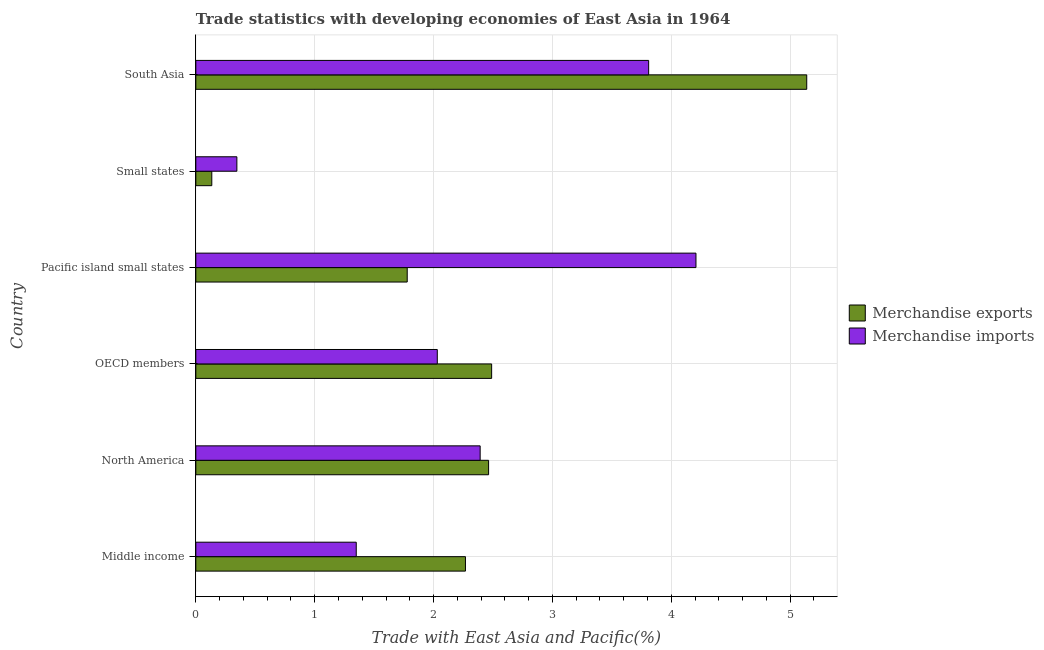How many different coloured bars are there?
Your answer should be compact. 2. Are the number of bars per tick equal to the number of legend labels?
Your response must be concise. Yes. What is the label of the 3rd group of bars from the top?
Your answer should be very brief. Pacific island small states. In how many cases, is the number of bars for a given country not equal to the number of legend labels?
Ensure brevity in your answer.  0. What is the merchandise exports in OECD members?
Ensure brevity in your answer.  2.49. Across all countries, what is the maximum merchandise imports?
Your response must be concise. 4.21. Across all countries, what is the minimum merchandise exports?
Make the answer very short. 0.13. In which country was the merchandise imports maximum?
Make the answer very short. Pacific island small states. In which country was the merchandise imports minimum?
Your response must be concise. Small states. What is the total merchandise imports in the graph?
Your response must be concise. 14.14. What is the difference between the merchandise imports in North America and that in Small states?
Provide a short and direct response. 2.05. What is the difference between the merchandise imports in Pacific island small states and the merchandise exports in Small states?
Ensure brevity in your answer.  4.07. What is the average merchandise imports per country?
Your answer should be compact. 2.36. What is the difference between the merchandise imports and merchandise exports in Small states?
Ensure brevity in your answer.  0.21. In how many countries, is the merchandise imports greater than 3.4 %?
Your response must be concise. 2. What is the ratio of the merchandise imports in North America to that in Pacific island small states?
Offer a terse response. 0.57. Is the difference between the merchandise exports in OECD members and Small states greater than the difference between the merchandise imports in OECD members and Small states?
Ensure brevity in your answer.  Yes. What is the difference between the highest and the second highest merchandise imports?
Ensure brevity in your answer.  0.4. What is the difference between the highest and the lowest merchandise exports?
Your response must be concise. 5.01. What does the 2nd bar from the top in OECD members represents?
Your response must be concise. Merchandise exports. What does the 1st bar from the bottom in OECD members represents?
Your response must be concise. Merchandise exports. Are all the bars in the graph horizontal?
Give a very brief answer. Yes. How many countries are there in the graph?
Make the answer very short. 6. What is the difference between two consecutive major ticks on the X-axis?
Keep it short and to the point. 1. How are the legend labels stacked?
Your response must be concise. Vertical. What is the title of the graph?
Keep it short and to the point. Trade statistics with developing economies of East Asia in 1964. Does "US$" appear as one of the legend labels in the graph?
Give a very brief answer. No. What is the label or title of the X-axis?
Your answer should be very brief. Trade with East Asia and Pacific(%). What is the label or title of the Y-axis?
Provide a succinct answer. Country. What is the Trade with East Asia and Pacific(%) in Merchandise exports in Middle income?
Your answer should be compact. 2.27. What is the Trade with East Asia and Pacific(%) of Merchandise imports in Middle income?
Offer a terse response. 1.35. What is the Trade with East Asia and Pacific(%) in Merchandise exports in North America?
Your response must be concise. 2.46. What is the Trade with East Asia and Pacific(%) in Merchandise imports in North America?
Provide a short and direct response. 2.39. What is the Trade with East Asia and Pacific(%) in Merchandise exports in OECD members?
Offer a terse response. 2.49. What is the Trade with East Asia and Pacific(%) of Merchandise imports in OECD members?
Keep it short and to the point. 2.03. What is the Trade with East Asia and Pacific(%) of Merchandise exports in Pacific island small states?
Provide a succinct answer. 1.78. What is the Trade with East Asia and Pacific(%) in Merchandise imports in Pacific island small states?
Offer a terse response. 4.21. What is the Trade with East Asia and Pacific(%) in Merchandise exports in Small states?
Keep it short and to the point. 0.13. What is the Trade with East Asia and Pacific(%) in Merchandise imports in Small states?
Your response must be concise. 0.35. What is the Trade with East Asia and Pacific(%) in Merchandise exports in South Asia?
Provide a succinct answer. 5.14. What is the Trade with East Asia and Pacific(%) in Merchandise imports in South Asia?
Provide a short and direct response. 3.81. Across all countries, what is the maximum Trade with East Asia and Pacific(%) in Merchandise exports?
Ensure brevity in your answer.  5.14. Across all countries, what is the maximum Trade with East Asia and Pacific(%) in Merchandise imports?
Provide a succinct answer. 4.21. Across all countries, what is the minimum Trade with East Asia and Pacific(%) of Merchandise exports?
Keep it short and to the point. 0.13. Across all countries, what is the minimum Trade with East Asia and Pacific(%) of Merchandise imports?
Your answer should be very brief. 0.35. What is the total Trade with East Asia and Pacific(%) of Merchandise exports in the graph?
Provide a succinct answer. 14.27. What is the total Trade with East Asia and Pacific(%) in Merchandise imports in the graph?
Offer a very short reply. 14.14. What is the difference between the Trade with East Asia and Pacific(%) in Merchandise exports in Middle income and that in North America?
Offer a terse response. -0.19. What is the difference between the Trade with East Asia and Pacific(%) in Merchandise imports in Middle income and that in North America?
Your response must be concise. -1.04. What is the difference between the Trade with East Asia and Pacific(%) in Merchandise exports in Middle income and that in OECD members?
Offer a terse response. -0.22. What is the difference between the Trade with East Asia and Pacific(%) of Merchandise imports in Middle income and that in OECD members?
Offer a terse response. -0.68. What is the difference between the Trade with East Asia and Pacific(%) in Merchandise exports in Middle income and that in Pacific island small states?
Your answer should be compact. 0.49. What is the difference between the Trade with East Asia and Pacific(%) of Merchandise imports in Middle income and that in Pacific island small states?
Offer a terse response. -2.86. What is the difference between the Trade with East Asia and Pacific(%) of Merchandise exports in Middle income and that in Small states?
Your response must be concise. 2.13. What is the difference between the Trade with East Asia and Pacific(%) in Merchandise imports in Middle income and that in Small states?
Ensure brevity in your answer.  1. What is the difference between the Trade with East Asia and Pacific(%) of Merchandise exports in Middle income and that in South Asia?
Provide a succinct answer. -2.87. What is the difference between the Trade with East Asia and Pacific(%) in Merchandise imports in Middle income and that in South Asia?
Your response must be concise. -2.46. What is the difference between the Trade with East Asia and Pacific(%) in Merchandise exports in North America and that in OECD members?
Give a very brief answer. -0.03. What is the difference between the Trade with East Asia and Pacific(%) of Merchandise imports in North America and that in OECD members?
Your response must be concise. 0.36. What is the difference between the Trade with East Asia and Pacific(%) of Merchandise exports in North America and that in Pacific island small states?
Offer a terse response. 0.68. What is the difference between the Trade with East Asia and Pacific(%) of Merchandise imports in North America and that in Pacific island small states?
Offer a very short reply. -1.82. What is the difference between the Trade with East Asia and Pacific(%) of Merchandise exports in North America and that in Small states?
Your answer should be very brief. 2.33. What is the difference between the Trade with East Asia and Pacific(%) in Merchandise imports in North America and that in Small states?
Ensure brevity in your answer.  2.05. What is the difference between the Trade with East Asia and Pacific(%) of Merchandise exports in North America and that in South Asia?
Your answer should be very brief. -2.68. What is the difference between the Trade with East Asia and Pacific(%) in Merchandise imports in North America and that in South Asia?
Offer a very short reply. -1.42. What is the difference between the Trade with East Asia and Pacific(%) in Merchandise exports in OECD members and that in Pacific island small states?
Ensure brevity in your answer.  0.71. What is the difference between the Trade with East Asia and Pacific(%) in Merchandise imports in OECD members and that in Pacific island small states?
Keep it short and to the point. -2.18. What is the difference between the Trade with East Asia and Pacific(%) of Merchandise exports in OECD members and that in Small states?
Provide a succinct answer. 2.35. What is the difference between the Trade with East Asia and Pacific(%) of Merchandise imports in OECD members and that in Small states?
Your answer should be very brief. 1.69. What is the difference between the Trade with East Asia and Pacific(%) of Merchandise exports in OECD members and that in South Asia?
Provide a short and direct response. -2.65. What is the difference between the Trade with East Asia and Pacific(%) in Merchandise imports in OECD members and that in South Asia?
Keep it short and to the point. -1.78. What is the difference between the Trade with East Asia and Pacific(%) in Merchandise exports in Pacific island small states and that in Small states?
Provide a succinct answer. 1.64. What is the difference between the Trade with East Asia and Pacific(%) in Merchandise imports in Pacific island small states and that in Small states?
Make the answer very short. 3.86. What is the difference between the Trade with East Asia and Pacific(%) in Merchandise exports in Pacific island small states and that in South Asia?
Offer a very short reply. -3.36. What is the difference between the Trade with East Asia and Pacific(%) in Merchandise imports in Pacific island small states and that in South Asia?
Offer a very short reply. 0.4. What is the difference between the Trade with East Asia and Pacific(%) of Merchandise exports in Small states and that in South Asia?
Your response must be concise. -5.01. What is the difference between the Trade with East Asia and Pacific(%) of Merchandise imports in Small states and that in South Asia?
Offer a terse response. -3.46. What is the difference between the Trade with East Asia and Pacific(%) of Merchandise exports in Middle income and the Trade with East Asia and Pacific(%) of Merchandise imports in North America?
Offer a terse response. -0.12. What is the difference between the Trade with East Asia and Pacific(%) in Merchandise exports in Middle income and the Trade with East Asia and Pacific(%) in Merchandise imports in OECD members?
Give a very brief answer. 0.24. What is the difference between the Trade with East Asia and Pacific(%) of Merchandise exports in Middle income and the Trade with East Asia and Pacific(%) of Merchandise imports in Pacific island small states?
Provide a short and direct response. -1.94. What is the difference between the Trade with East Asia and Pacific(%) of Merchandise exports in Middle income and the Trade with East Asia and Pacific(%) of Merchandise imports in Small states?
Make the answer very short. 1.92. What is the difference between the Trade with East Asia and Pacific(%) of Merchandise exports in Middle income and the Trade with East Asia and Pacific(%) of Merchandise imports in South Asia?
Your answer should be compact. -1.54. What is the difference between the Trade with East Asia and Pacific(%) in Merchandise exports in North America and the Trade with East Asia and Pacific(%) in Merchandise imports in OECD members?
Ensure brevity in your answer.  0.43. What is the difference between the Trade with East Asia and Pacific(%) in Merchandise exports in North America and the Trade with East Asia and Pacific(%) in Merchandise imports in Pacific island small states?
Offer a terse response. -1.74. What is the difference between the Trade with East Asia and Pacific(%) of Merchandise exports in North America and the Trade with East Asia and Pacific(%) of Merchandise imports in Small states?
Provide a short and direct response. 2.12. What is the difference between the Trade with East Asia and Pacific(%) of Merchandise exports in North America and the Trade with East Asia and Pacific(%) of Merchandise imports in South Asia?
Make the answer very short. -1.35. What is the difference between the Trade with East Asia and Pacific(%) of Merchandise exports in OECD members and the Trade with East Asia and Pacific(%) of Merchandise imports in Pacific island small states?
Your answer should be compact. -1.72. What is the difference between the Trade with East Asia and Pacific(%) of Merchandise exports in OECD members and the Trade with East Asia and Pacific(%) of Merchandise imports in Small states?
Provide a succinct answer. 2.14. What is the difference between the Trade with East Asia and Pacific(%) in Merchandise exports in OECD members and the Trade with East Asia and Pacific(%) in Merchandise imports in South Asia?
Provide a short and direct response. -1.32. What is the difference between the Trade with East Asia and Pacific(%) in Merchandise exports in Pacific island small states and the Trade with East Asia and Pacific(%) in Merchandise imports in Small states?
Provide a succinct answer. 1.43. What is the difference between the Trade with East Asia and Pacific(%) of Merchandise exports in Pacific island small states and the Trade with East Asia and Pacific(%) of Merchandise imports in South Asia?
Your answer should be very brief. -2.03. What is the difference between the Trade with East Asia and Pacific(%) in Merchandise exports in Small states and the Trade with East Asia and Pacific(%) in Merchandise imports in South Asia?
Your response must be concise. -3.68. What is the average Trade with East Asia and Pacific(%) in Merchandise exports per country?
Give a very brief answer. 2.38. What is the average Trade with East Asia and Pacific(%) of Merchandise imports per country?
Your answer should be very brief. 2.36. What is the difference between the Trade with East Asia and Pacific(%) in Merchandise exports and Trade with East Asia and Pacific(%) in Merchandise imports in Middle income?
Ensure brevity in your answer.  0.92. What is the difference between the Trade with East Asia and Pacific(%) of Merchandise exports and Trade with East Asia and Pacific(%) of Merchandise imports in North America?
Keep it short and to the point. 0.07. What is the difference between the Trade with East Asia and Pacific(%) in Merchandise exports and Trade with East Asia and Pacific(%) in Merchandise imports in OECD members?
Give a very brief answer. 0.46. What is the difference between the Trade with East Asia and Pacific(%) of Merchandise exports and Trade with East Asia and Pacific(%) of Merchandise imports in Pacific island small states?
Provide a short and direct response. -2.43. What is the difference between the Trade with East Asia and Pacific(%) of Merchandise exports and Trade with East Asia and Pacific(%) of Merchandise imports in Small states?
Ensure brevity in your answer.  -0.21. What is the difference between the Trade with East Asia and Pacific(%) of Merchandise exports and Trade with East Asia and Pacific(%) of Merchandise imports in South Asia?
Provide a succinct answer. 1.33. What is the ratio of the Trade with East Asia and Pacific(%) in Merchandise exports in Middle income to that in North America?
Your response must be concise. 0.92. What is the ratio of the Trade with East Asia and Pacific(%) in Merchandise imports in Middle income to that in North America?
Provide a succinct answer. 0.56. What is the ratio of the Trade with East Asia and Pacific(%) in Merchandise exports in Middle income to that in OECD members?
Your answer should be very brief. 0.91. What is the ratio of the Trade with East Asia and Pacific(%) of Merchandise imports in Middle income to that in OECD members?
Make the answer very short. 0.66. What is the ratio of the Trade with East Asia and Pacific(%) in Merchandise exports in Middle income to that in Pacific island small states?
Provide a succinct answer. 1.28. What is the ratio of the Trade with East Asia and Pacific(%) in Merchandise imports in Middle income to that in Pacific island small states?
Your answer should be compact. 0.32. What is the ratio of the Trade with East Asia and Pacific(%) in Merchandise exports in Middle income to that in Small states?
Your response must be concise. 16.89. What is the ratio of the Trade with East Asia and Pacific(%) in Merchandise imports in Middle income to that in Small states?
Keep it short and to the point. 3.91. What is the ratio of the Trade with East Asia and Pacific(%) of Merchandise exports in Middle income to that in South Asia?
Ensure brevity in your answer.  0.44. What is the ratio of the Trade with East Asia and Pacific(%) of Merchandise imports in Middle income to that in South Asia?
Make the answer very short. 0.35. What is the ratio of the Trade with East Asia and Pacific(%) of Merchandise imports in North America to that in OECD members?
Your answer should be very brief. 1.18. What is the ratio of the Trade with East Asia and Pacific(%) of Merchandise exports in North America to that in Pacific island small states?
Make the answer very short. 1.38. What is the ratio of the Trade with East Asia and Pacific(%) in Merchandise imports in North America to that in Pacific island small states?
Make the answer very short. 0.57. What is the ratio of the Trade with East Asia and Pacific(%) of Merchandise exports in North America to that in Small states?
Your answer should be very brief. 18.34. What is the ratio of the Trade with East Asia and Pacific(%) in Merchandise imports in North America to that in Small states?
Make the answer very short. 6.93. What is the ratio of the Trade with East Asia and Pacific(%) in Merchandise exports in North America to that in South Asia?
Your response must be concise. 0.48. What is the ratio of the Trade with East Asia and Pacific(%) in Merchandise imports in North America to that in South Asia?
Offer a terse response. 0.63. What is the ratio of the Trade with East Asia and Pacific(%) in Merchandise exports in OECD members to that in Pacific island small states?
Provide a short and direct response. 1.4. What is the ratio of the Trade with East Asia and Pacific(%) in Merchandise imports in OECD members to that in Pacific island small states?
Your answer should be compact. 0.48. What is the ratio of the Trade with East Asia and Pacific(%) in Merchandise exports in OECD members to that in Small states?
Offer a terse response. 18.53. What is the ratio of the Trade with East Asia and Pacific(%) of Merchandise imports in OECD members to that in Small states?
Keep it short and to the point. 5.88. What is the ratio of the Trade with East Asia and Pacific(%) of Merchandise exports in OECD members to that in South Asia?
Your response must be concise. 0.48. What is the ratio of the Trade with East Asia and Pacific(%) in Merchandise imports in OECD members to that in South Asia?
Offer a terse response. 0.53. What is the ratio of the Trade with East Asia and Pacific(%) in Merchandise exports in Pacific island small states to that in Small states?
Keep it short and to the point. 13.24. What is the ratio of the Trade with East Asia and Pacific(%) of Merchandise imports in Pacific island small states to that in Small states?
Keep it short and to the point. 12.19. What is the ratio of the Trade with East Asia and Pacific(%) of Merchandise exports in Pacific island small states to that in South Asia?
Your response must be concise. 0.35. What is the ratio of the Trade with East Asia and Pacific(%) of Merchandise imports in Pacific island small states to that in South Asia?
Keep it short and to the point. 1.1. What is the ratio of the Trade with East Asia and Pacific(%) in Merchandise exports in Small states to that in South Asia?
Offer a very short reply. 0.03. What is the ratio of the Trade with East Asia and Pacific(%) in Merchandise imports in Small states to that in South Asia?
Your answer should be compact. 0.09. What is the difference between the highest and the second highest Trade with East Asia and Pacific(%) of Merchandise exports?
Give a very brief answer. 2.65. What is the difference between the highest and the second highest Trade with East Asia and Pacific(%) of Merchandise imports?
Make the answer very short. 0.4. What is the difference between the highest and the lowest Trade with East Asia and Pacific(%) of Merchandise exports?
Keep it short and to the point. 5.01. What is the difference between the highest and the lowest Trade with East Asia and Pacific(%) of Merchandise imports?
Your answer should be compact. 3.86. 